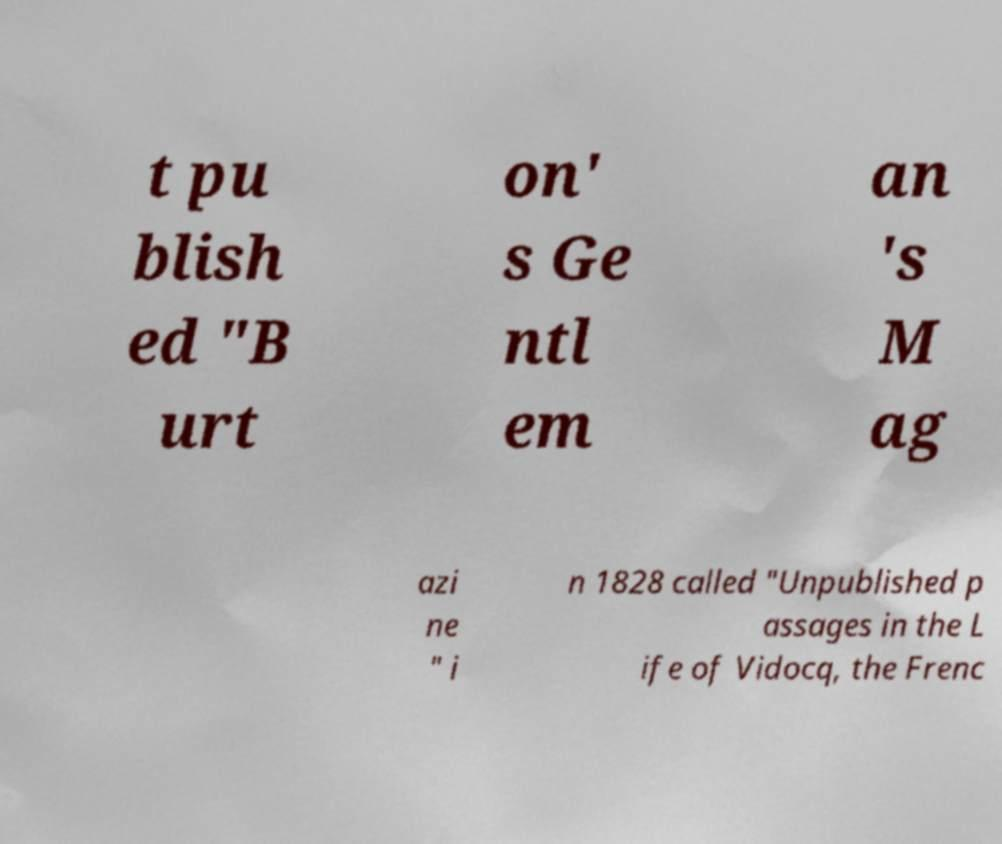Could you assist in decoding the text presented in this image and type it out clearly? t pu blish ed "B urt on' s Ge ntl em an 's M ag azi ne " i n 1828 called "Unpublished p assages in the L ife of Vidocq, the Frenc 